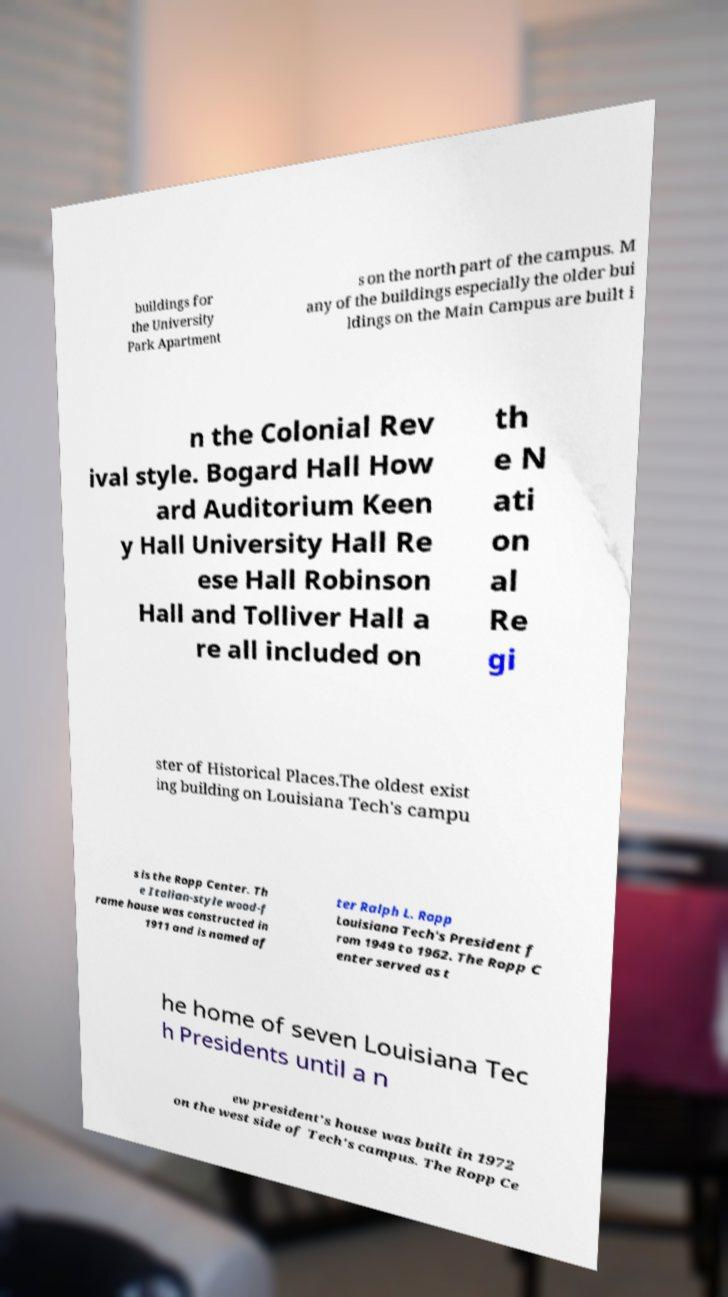Can you read and provide the text displayed in the image?This photo seems to have some interesting text. Can you extract and type it out for me? buildings for the University Park Apartment s on the north part of the campus. M any of the buildings especially the older bui ldings on the Main Campus are built i n the Colonial Rev ival style. Bogard Hall How ard Auditorium Keen y Hall University Hall Re ese Hall Robinson Hall and Tolliver Hall a re all included on th e N ati on al Re gi ster of Historical Places.The oldest exist ing building on Louisiana Tech's campu s is the Ropp Center. Th e Italian-style wood-f rame house was constructed in 1911 and is named af ter Ralph L. Ropp Louisiana Tech's President f rom 1949 to 1962. The Ropp C enter served as t he home of seven Louisiana Tec h Presidents until a n ew president's house was built in 1972 on the west side of Tech's campus. The Ropp Ce 